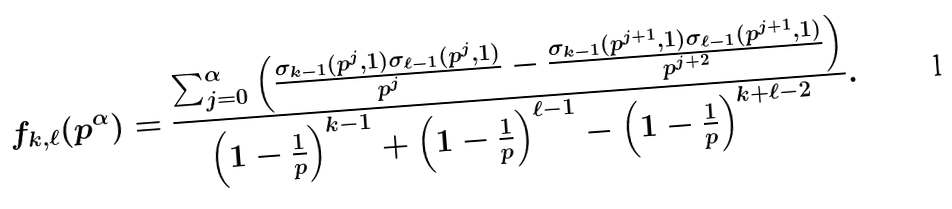<formula> <loc_0><loc_0><loc_500><loc_500>f _ { k , \ell } ( p ^ { \alpha } ) = \frac { \sum _ { j = 0 } ^ { \alpha } \left ( \frac { \sigma _ { k - 1 } ( p ^ { j } , 1 ) \sigma _ { \ell - 1 } ( p ^ { j } , 1 ) } { p ^ { j } } - \frac { \sigma _ { k - 1 } ( p ^ { j + 1 } , 1 ) \sigma _ { \ell - 1 } ( p ^ { j + 1 } , 1 ) } { p ^ { j + 2 } } \right ) } { \left ( 1 - \frac { 1 } { p } \right ) ^ { k - 1 } + \left ( 1 - \frac { 1 } { p } \right ) ^ { \ell - 1 } - \left ( 1 - \frac { 1 } { p } \right ) ^ { k + \ell - 2 } } .</formula> 